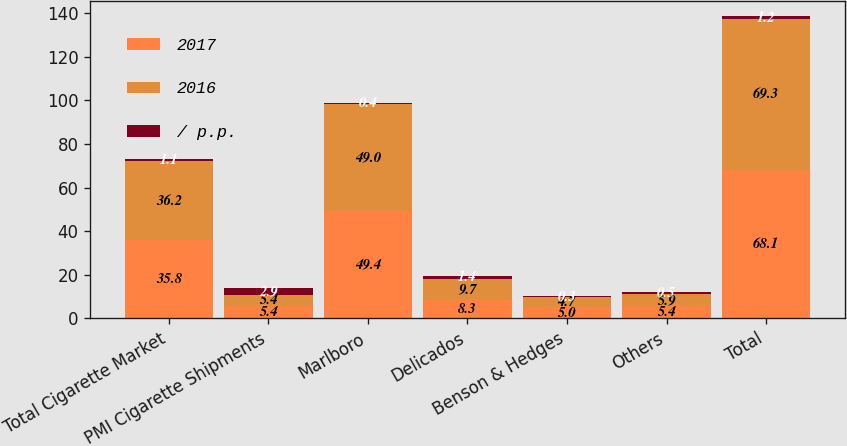Convert chart to OTSL. <chart><loc_0><loc_0><loc_500><loc_500><stacked_bar_chart><ecel><fcel>Total Cigarette Market<fcel>PMI Cigarette Shipments<fcel>Marlboro<fcel>Delicados<fcel>Benson & Hedges<fcel>Others<fcel>Total<nl><fcel>2017<fcel>35.8<fcel>5.4<fcel>49.4<fcel>8.3<fcel>5<fcel>5.4<fcel>68.1<nl><fcel>2016<fcel>36.2<fcel>5.4<fcel>49<fcel>9.7<fcel>4.7<fcel>5.9<fcel>69.3<nl><fcel>/ p.p.<fcel>1.1<fcel>2.9<fcel>0.4<fcel>1.4<fcel>0.3<fcel>0.5<fcel>1.2<nl></chart> 